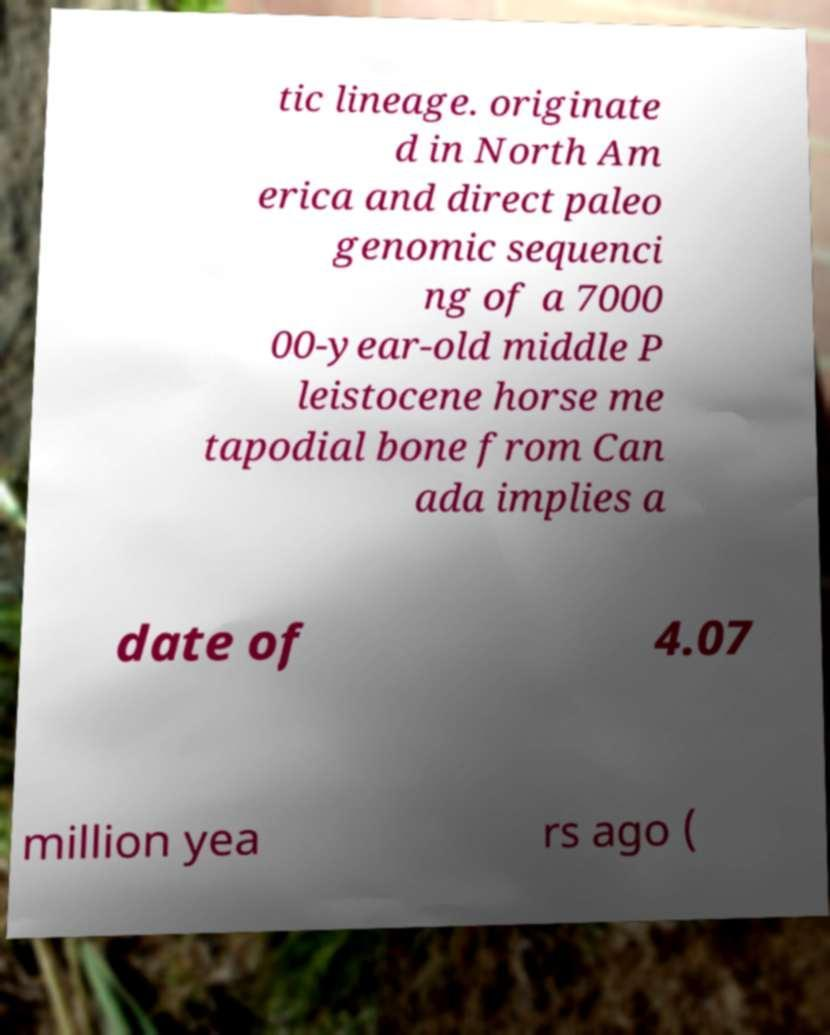Could you extract and type out the text from this image? tic lineage. originate d in North Am erica and direct paleo genomic sequenci ng of a 7000 00-year-old middle P leistocene horse me tapodial bone from Can ada implies a date of 4.07 million yea rs ago ( 